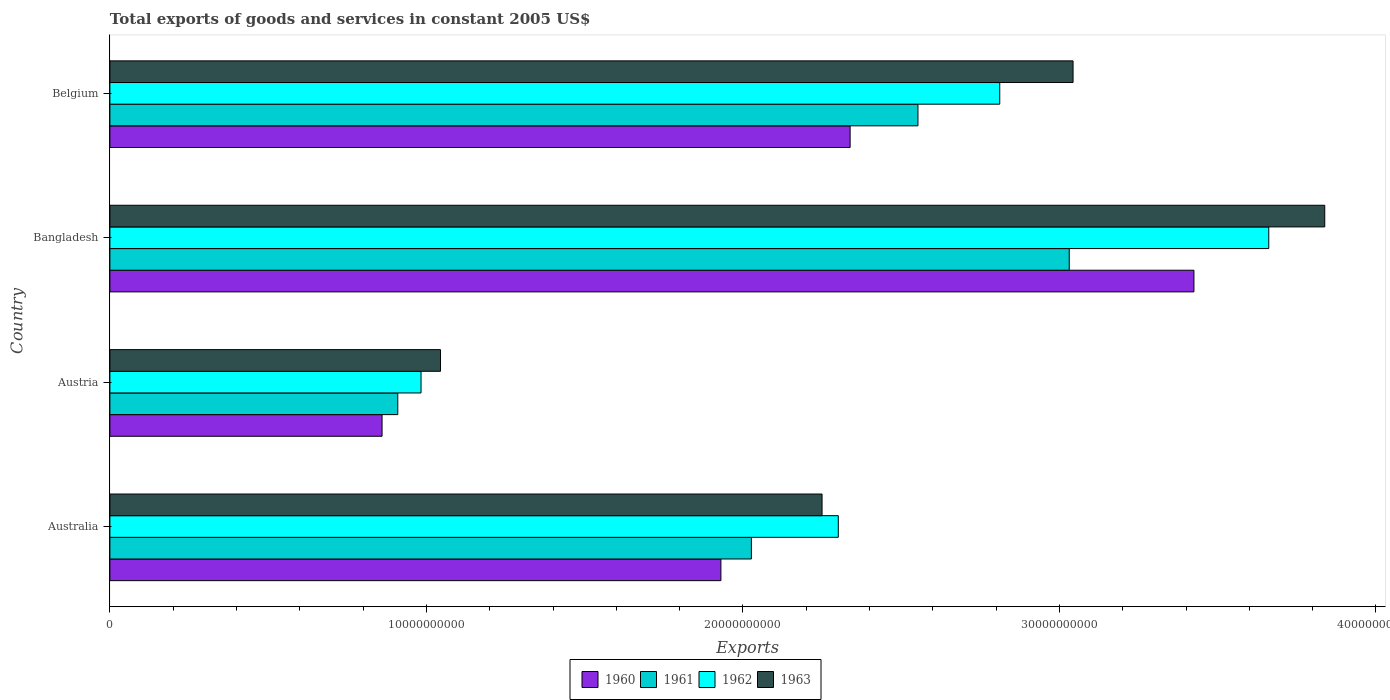How many groups of bars are there?
Your answer should be compact. 4. Are the number of bars per tick equal to the number of legend labels?
Your response must be concise. Yes. What is the total exports of goods and services in 1961 in Austria?
Make the answer very short. 9.10e+09. Across all countries, what is the maximum total exports of goods and services in 1962?
Provide a short and direct response. 3.66e+1. Across all countries, what is the minimum total exports of goods and services in 1961?
Offer a terse response. 9.10e+09. In which country was the total exports of goods and services in 1962 maximum?
Keep it short and to the point. Bangladesh. What is the total total exports of goods and services in 1963 in the graph?
Your response must be concise. 1.02e+11. What is the difference between the total exports of goods and services in 1961 in Bangladesh and that in Belgium?
Offer a terse response. 4.78e+09. What is the difference between the total exports of goods and services in 1963 in Austria and the total exports of goods and services in 1962 in Australia?
Provide a succinct answer. -1.26e+1. What is the average total exports of goods and services in 1962 per country?
Your response must be concise. 2.44e+1. What is the difference between the total exports of goods and services in 1961 and total exports of goods and services in 1963 in Bangladesh?
Provide a succinct answer. -8.07e+09. What is the ratio of the total exports of goods and services in 1960 in Austria to that in Belgium?
Your response must be concise. 0.37. Is the total exports of goods and services in 1960 in Australia less than that in Bangladesh?
Keep it short and to the point. Yes. What is the difference between the highest and the second highest total exports of goods and services in 1963?
Provide a succinct answer. 7.95e+09. What is the difference between the highest and the lowest total exports of goods and services in 1962?
Give a very brief answer. 2.68e+1. In how many countries, is the total exports of goods and services in 1960 greater than the average total exports of goods and services in 1960 taken over all countries?
Offer a very short reply. 2. Is it the case that in every country, the sum of the total exports of goods and services in 1961 and total exports of goods and services in 1963 is greater than the sum of total exports of goods and services in 1962 and total exports of goods and services in 1960?
Keep it short and to the point. No. What does the 1st bar from the bottom in Bangladesh represents?
Keep it short and to the point. 1960. How many bars are there?
Your answer should be very brief. 16. How many countries are there in the graph?
Offer a very short reply. 4. What is the difference between two consecutive major ticks on the X-axis?
Your answer should be compact. 1.00e+1. Are the values on the major ticks of X-axis written in scientific E-notation?
Keep it short and to the point. No. Does the graph contain any zero values?
Make the answer very short. No. Does the graph contain grids?
Ensure brevity in your answer.  No. Where does the legend appear in the graph?
Offer a terse response. Bottom center. How are the legend labels stacked?
Your answer should be compact. Horizontal. What is the title of the graph?
Ensure brevity in your answer.  Total exports of goods and services in constant 2005 US$. What is the label or title of the X-axis?
Keep it short and to the point. Exports. What is the Exports of 1960 in Australia?
Provide a short and direct response. 1.93e+1. What is the Exports in 1961 in Australia?
Ensure brevity in your answer.  2.03e+1. What is the Exports of 1962 in Australia?
Offer a very short reply. 2.30e+1. What is the Exports in 1963 in Australia?
Give a very brief answer. 2.25e+1. What is the Exports in 1960 in Austria?
Offer a terse response. 8.60e+09. What is the Exports in 1961 in Austria?
Your answer should be very brief. 9.10e+09. What is the Exports of 1962 in Austria?
Ensure brevity in your answer.  9.83e+09. What is the Exports of 1963 in Austria?
Your answer should be compact. 1.04e+1. What is the Exports of 1960 in Bangladesh?
Make the answer very short. 3.42e+1. What is the Exports in 1961 in Bangladesh?
Your response must be concise. 3.03e+1. What is the Exports of 1962 in Bangladesh?
Provide a short and direct response. 3.66e+1. What is the Exports in 1963 in Bangladesh?
Provide a succinct answer. 3.84e+1. What is the Exports in 1960 in Belgium?
Your response must be concise. 2.34e+1. What is the Exports in 1961 in Belgium?
Your answer should be compact. 2.55e+1. What is the Exports of 1962 in Belgium?
Your response must be concise. 2.81e+1. What is the Exports in 1963 in Belgium?
Make the answer very short. 3.04e+1. Across all countries, what is the maximum Exports in 1960?
Keep it short and to the point. 3.42e+1. Across all countries, what is the maximum Exports in 1961?
Offer a terse response. 3.03e+1. Across all countries, what is the maximum Exports in 1962?
Provide a succinct answer. 3.66e+1. Across all countries, what is the maximum Exports of 1963?
Your answer should be very brief. 3.84e+1. Across all countries, what is the minimum Exports in 1960?
Your answer should be very brief. 8.60e+09. Across all countries, what is the minimum Exports of 1961?
Provide a short and direct response. 9.10e+09. Across all countries, what is the minimum Exports in 1962?
Your response must be concise. 9.83e+09. Across all countries, what is the minimum Exports in 1963?
Give a very brief answer. 1.04e+1. What is the total Exports of 1960 in the graph?
Offer a very short reply. 8.55e+1. What is the total Exports in 1961 in the graph?
Provide a short and direct response. 8.52e+1. What is the total Exports of 1962 in the graph?
Your response must be concise. 9.76e+1. What is the total Exports in 1963 in the graph?
Make the answer very short. 1.02e+11. What is the difference between the Exports in 1960 in Australia and that in Austria?
Make the answer very short. 1.07e+1. What is the difference between the Exports in 1961 in Australia and that in Austria?
Offer a terse response. 1.12e+1. What is the difference between the Exports of 1962 in Australia and that in Austria?
Keep it short and to the point. 1.32e+1. What is the difference between the Exports in 1963 in Australia and that in Austria?
Provide a succinct answer. 1.21e+1. What is the difference between the Exports in 1960 in Australia and that in Bangladesh?
Offer a terse response. -1.49e+1. What is the difference between the Exports in 1961 in Australia and that in Bangladesh?
Offer a terse response. -1.00e+1. What is the difference between the Exports in 1962 in Australia and that in Bangladesh?
Provide a succinct answer. -1.36e+1. What is the difference between the Exports in 1963 in Australia and that in Bangladesh?
Make the answer very short. -1.59e+1. What is the difference between the Exports in 1960 in Australia and that in Belgium?
Ensure brevity in your answer.  -4.08e+09. What is the difference between the Exports of 1961 in Australia and that in Belgium?
Offer a terse response. -5.26e+09. What is the difference between the Exports of 1962 in Australia and that in Belgium?
Provide a succinct answer. -5.10e+09. What is the difference between the Exports in 1963 in Australia and that in Belgium?
Your answer should be compact. -7.93e+09. What is the difference between the Exports in 1960 in Austria and that in Bangladesh?
Offer a terse response. -2.57e+1. What is the difference between the Exports in 1961 in Austria and that in Bangladesh?
Your answer should be compact. -2.12e+1. What is the difference between the Exports in 1962 in Austria and that in Bangladesh?
Your answer should be compact. -2.68e+1. What is the difference between the Exports of 1963 in Austria and that in Bangladesh?
Provide a short and direct response. -2.79e+1. What is the difference between the Exports in 1960 in Austria and that in Belgium?
Keep it short and to the point. -1.48e+1. What is the difference between the Exports of 1961 in Austria and that in Belgium?
Your response must be concise. -1.64e+1. What is the difference between the Exports in 1962 in Austria and that in Belgium?
Your answer should be very brief. -1.83e+1. What is the difference between the Exports of 1963 in Austria and that in Belgium?
Ensure brevity in your answer.  -2.00e+1. What is the difference between the Exports of 1960 in Bangladesh and that in Belgium?
Give a very brief answer. 1.09e+1. What is the difference between the Exports of 1961 in Bangladesh and that in Belgium?
Your response must be concise. 4.78e+09. What is the difference between the Exports in 1962 in Bangladesh and that in Belgium?
Your response must be concise. 8.50e+09. What is the difference between the Exports in 1963 in Bangladesh and that in Belgium?
Your answer should be compact. 7.95e+09. What is the difference between the Exports of 1960 in Australia and the Exports of 1961 in Austria?
Give a very brief answer. 1.02e+1. What is the difference between the Exports of 1960 in Australia and the Exports of 1962 in Austria?
Offer a terse response. 9.47e+09. What is the difference between the Exports of 1960 in Australia and the Exports of 1963 in Austria?
Your response must be concise. 8.86e+09. What is the difference between the Exports in 1961 in Australia and the Exports in 1962 in Austria?
Provide a succinct answer. 1.04e+1. What is the difference between the Exports of 1961 in Australia and the Exports of 1963 in Austria?
Your response must be concise. 9.82e+09. What is the difference between the Exports of 1962 in Australia and the Exports of 1963 in Austria?
Keep it short and to the point. 1.26e+1. What is the difference between the Exports in 1960 in Australia and the Exports in 1961 in Bangladesh?
Your response must be concise. -1.10e+1. What is the difference between the Exports of 1960 in Australia and the Exports of 1962 in Bangladesh?
Provide a succinct answer. -1.73e+1. What is the difference between the Exports of 1960 in Australia and the Exports of 1963 in Bangladesh?
Ensure brevity in your answer.  -1.91e+1. What is the difference between the Exports of 1961 in Australia and the Exports of 1962 in Bangladesh?
Provide a short and direct response. -1.63e+1. What is the difference between the Exports of 1961 in Australia and the Exports of 1963 in Bangladesh?
Your answer should be very brief. -1.81e+1. What is the difference between the Exports of 1962 in Australia and the Exports of 1963 in Bangladesh?
Give a very brief answer. -1.54e+1. What is the difference between the Exports of 1960 in Australia and the Exports of 1961 in Belgium?
Make the answer very short. -6.23e+09. What is the difference between the Exports in 1960 in Australia and the Exports in 1962 in Belgium?
Offer a terse response. -8.81e+09. What is the difference between the Exports of 1960 in Australia and the Exports of 1963 in Belgium?
Your answer should be very brief. -1.11e+1. What is the difference between the Exports in 1961 in Australia and the Exports in 1962 in Belgium?
Ensure brevity in your answer.  -7.85e+09. What is the difference between the Exports of 1961 in Australia and the Exports of 1963 in Belgium?
Make the answer very short. -1.02e+1. What is the difference between the Exports in 1962 in Australia and the Exports in 1963 in Belgium?
Give a very brief answer. -7.42e+09. What is the difference between the Exports of 1960 in Austria and the Exports of 1961 in Bangladesh?
Your answer should be compact. -2.17e+1. What is the difference between the Exports in 1960 in Austria and the Exports in 1962 in Bangladesh?
Provide a succinct answer. -2.80e+1. What is the difference between the Exports of 1960 in Austria and the Exports of 1963 in Bangladesh?
Provide a short and direct response. -2.98e+1. What is the difference between the Exports in 1961 in Austria and the Exports in 1962 in Bangladesh?
Provide a succinct answer. -2.75e+1. What is the difference between the Exports of 1961 in Austria and the Exports of 1963 in Bangladesh?
Ensure brevity in your answer.  -2.93e+1. What is the difference between the Exports of 1962 in Austria and the Exports of 1963 in Bangladesh?
Keep it short and to the point. -2.86e+1. What is the difference between the Exports in 1960 in Austria and the Exports in 1961 in Belgium?
Your answer should be very brief. -1.69e+1. What is the difference between the Exports of 1960 in Austria and the Exports of 1962 in Belgium?
Your answer should be compact. -1.95e+1. What is the difference between the Exports in 1960 in Austria and the Exports in 1963 in Belgium?
Your response must be concise. -2.18e+1. What is the difference between the Exports of 1961 in Austria and the Exports of 1962 in Belgium?
Ensure brevity in your answer.  -1.90e+1. What is the difference between the Exports of 1961 in Austria and the Exports of 1963 in Belgium?
Offer a very short reply. -2.13e+1. What is the difference between the Exports in 1962 in Austria and the Exports in 1963 in Belgium?
Your answer should be compact. -2.06e+1. What is the difference between the Exports of 1960 in Bangladesh and the Exports of 1961 in Belgium?
Your response must be concise. 8.72e+09. What is the difference between the Exports of 1960 in Bangladesh and the Exports of 1962 in Belgium?
Your response must be concise. 6.14e+09. What is the difference between the Exports in 1960 in Bangladesh and the Exports in 1963 in Belgium?
Provide a short and direct response. 3.82e+09. What is the difference between the Exports in 1961 in Bangladesh and the Exports in 1962 in Belgium?
Provide a succinct answer. 2.20e+09. What is the difference between the Exports in 1961 in Bangladesh and the Exports in 1963 in Belgium?
Provide a short and direct response. -1.20e+08. What is the difference between the Exports in 1962 in Bangladesh and the Exports in 1963 in Belgium?
Provide a succinct answer. 6.18e+09. What is the average Exports of 1960 per country?
Keep it short and to the point. 2.14e+1. What is the average Exports of 1961 per country?
Ensure brevity in your answer.  2.13e+1. What is the average Exports in 1962 per country?
Your response must be concise. 2.44e+1. What is the average Exports in 1963 per country?
Offer a terse response. 2.54e+1. What is the difference between the Exports in 1960 and Exports in 1961 in Australia?
Your answer should be very brief. -9.63e+08. What is the difference between the Exports in 1960 and Exports in 1962 in Australia?
Provide a short and direct response. -3.71e+09. What is the difference between the Exports of 1960 and Exports of 1963 in Australia?
Ensure brevity in your answer.  -3.20e+09. What is the difference between the Exports in 1961 and Exports in 1962 in Australia?
Offer a terse response. -2.75e+09. What is the difference between the Exports in 1961 and Exports in 1963 in Australia?
Give a very brief answer. -2.23e+09. What is the difference between the Exports in 1962 and Exports in 1963 in Australia?
Ensure brevity in your answer.  5.13e+08. What is the difference between the Exports of 1960 and Exports of 1961 in Austria?
Your response must be concise. -4.96e+08. What is the difference between the Exports of 1960 and Exports of 1962 in Austria?
Ensure brevity in your answer.  -1.23e+09. What is the difference between the Exports in 1960 and Exports in 1963 in Austria?
Your answer should be compact. -1.85e+09. What is the difference between the Exports in 1961 and Exports in 1962 in Austria?
Provide a short and direct response. -7.35e+08. What is the difference between the Exports of 1961 and Exports of 1963 in Austria?
Offer a terse response. -1.35e+09. What is the difference between the Exports in 1962 and Exports in 1963 in Austria?
Give a very brief answer. -6.16e+08. What is the difference between the Exports of 1960 and Exports of 1961 in Bangladesh?
Make the answer very short. 3.94e+09. What is the difference between the Exports in 1960 and Exports in 1962 in Bangladesh?
Offer a very short reply. -2.36e+09. What is the difference between the Exports in 1960 and Exports in 1963 in Bangladesh?
Keep it short and to the point. -4.13e+09. What is the difference between the Exports in 1961 and Exports in 1962 in Bangladesh?
Keep it short and to the point. -6.30e+09. What is the difference between the Exports in 1961 and Exports in 1963 in Bangladesh?
Your answer should be very brief. -8.07e+09. What is the difference between the Exports in 1962 and Exports in 1963 in Bangladesh?
Provide a succinct answer. -1.77e+09. What is the difference between the Exports in 1960 and Exports in 1961 in Belgium?
Provide a short and direct response. -2.14e+09. What is the difference between the Exports of 1960 and Exports of 1962 in Belgium?
Offer a very short reply. -4.73e+09. What is the difference between the Exports of 1960 and Exports of 1963 in Belgium?
Your answer should be compact. -7.04e+09. What is the difference between the Exports in 1961 and Exports in 1962 in Belgium?
Provide a succinct answer. -2.58e+09. What is the difference between the Exports in 1961 and Exports in 1963 in Belgium?
Make the answer very short. -4.90e+09. What is the difference between the Exports in 1962 and Exports in 1963 in Belgium?
Provide a short and direct response. -2.32e+09. What is the ratio of the Exports of 1960 in Australia to that in Austria?
Provide a succinct answer. 2.25. What is the ratio of the Exports in 1961 in Australia to that in Austria?
Ensure brevity in your answer.  2.23. What is the ratio of the Exports of 1962 in Australia to that in Austria?
Your answer should be compact. 2.34. What is the ratio of the Exports in 1963 in Australia to that in Austria?
Your answer should be very brief. 2.15. What is the ratio of the Exports in 1960 in Australia to that in Bangladesh?
Offer a very short reply. 0.56. What is the ratio of the Exports in 1961 in Australia to that in Bangladesh?
Make the answer very short. 0.67. What is the ratio of the Exports of 1962 in Australia to that in Bangladesh?
Your answer should be compact. 0.63. What is the ratio of the Exports in 1963 in Australia to that in Bangladesh?
Provide a short and direct response. 0.59. What is the ratio of the Exports in 1960 in Australia to that in Belgium?
Ensure brevity in your answer.  0.83. What is the ratio of the Exports in 1961 in Australia to that in Belgium?
Your answer should be very brief. 0.79. What is the ratio of the Exports in 1962 in Australia to that in Belgium?
Offer a terse response. 0.82. What is the ratio of the Exports of 1963 in Australia to that in Belgium?
Ensure brevity in your answer.  0.74. What is the ratio of the Exports of 1960 in Austria to that in Bangladesh?
Keep it short and to the point. 0.25. What is the ratio of the Exports of 1961 in Austria to that in Bangladesh?
Give a very brief answer. 0.3. What is the ratio of the Exports in 1962 in Austria to that in Bangladesh?
Make the answer very short. 0.27. What is the ratio of the Exports in 1963 in Austria to that in Bangladesh?
Your answer should be very brief. 0.27. What is the ratio of the Exports in 1960 in Austria to that in Belgium?
Make the answer very short. 0.37. What is the ratio of the Exports in 1961 in Austria to that in Belgium?
Make the answer very short. 0.36. What is the ratio of the Exports of 1962 in Austria to that in Belgium?
Offer a very short reply. 0.35. What is the ratio of the Exports in 1963 in Austria to that in Belgium?
Provide a succinct answer. 0.34. What is the ratio of the Exports in 1960 in Bangladesh to that in Belgium?
Provide a succinct answer. 1.46. What is the ratio of the Exports in 1961 in Bangladesh to that in Belgium?
Your answer should be compact. 1.19. What is the ratio of the Exports of 1962 in Bangladesh to that in Belgium?
Offer a terse response. 1.3. What is the ratio of the Exports of 1963 in Bangladesh to that in Belgium?
Provide a short and direct response. 1.26. What is the difference between the highest and the second highest Exports of 1960?
Your answer should be very brief. 1.09e+1. What is the difference between the highest and the second highest Exports of 1961?
Keep it short and to the point. 4.78e+09. What is the difference between the highest and the second highest Exports of 1962?
Make the answer very short. 8.50e+09. What is the difference between the highest and the second highest Exports of 1963?
Your response must be concise. 7.95e+09. What is the difference between the highest and the lowest Exports of 1960?
Give a very brief answer. 2.57e+1. What is the difference between the highest and the lowest Exports of 1961?
Make the answer very short. 2.12e+1. What is the difference between the highest and the lowest Exports in 1962?
Your answer should be very brief. 2.68e+1. What is the difference between the highest and the lowest Exports of 1963?
Offer a terse response. 2.79e+1. 